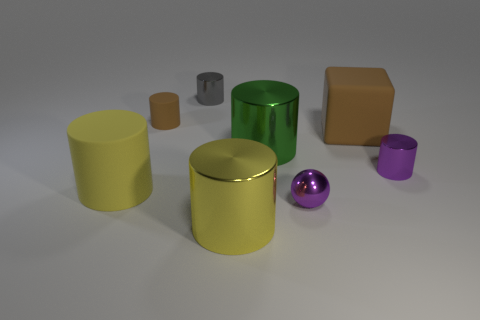Subtract all brown rubber cylinders. How many cylinders are left? 5 Subtract all cylinders. How many objects are left? 2 Subtract 5 cylinders. How many cylinders are left? 1 Subtract all big blue metallic cubes. Subtract all tiny rubber cylinders. How many objects are left? 7 Add 5 large rubber blocks. How many large rubber blocks are left? 6 Add 3 green metal objects. How many green metal objects exist? 4 Add 2 small green cylinders. How many objects exist? 10 Subtract all purple cylinders. How many cylinders are left? 5 Subtract 0 red blocks. How many objects are left? 8 Subtract all red cylinders. Subtract all green balls. How many cylinders are left? 6 